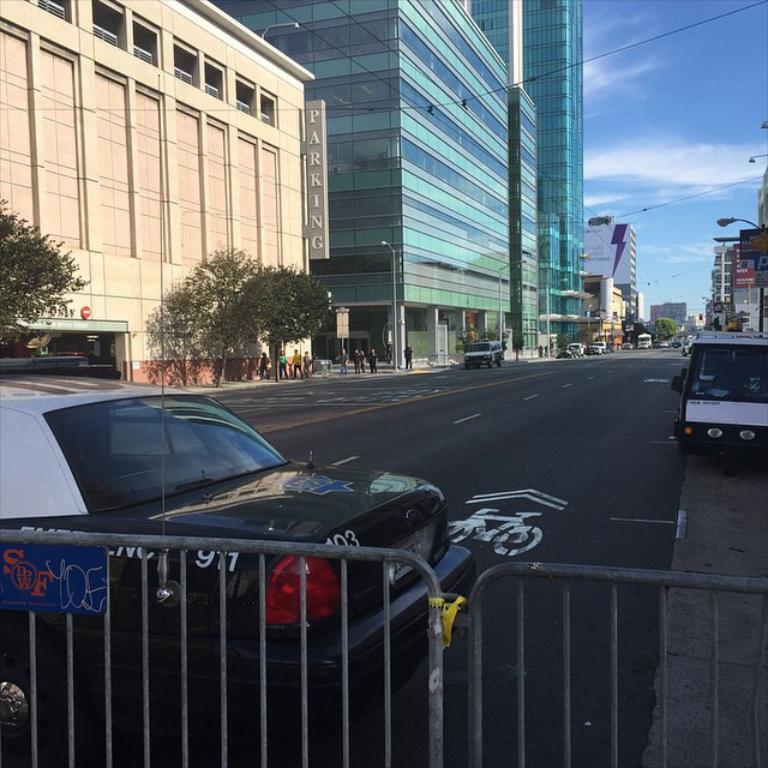In one or two sentences, can you explain what this image depicts? This is the street view of a city, in this image there are a few cars parked on the road and there are a few people walking on the pavement and there are buildings, in front of the buildings there are lamp posts and trees. 